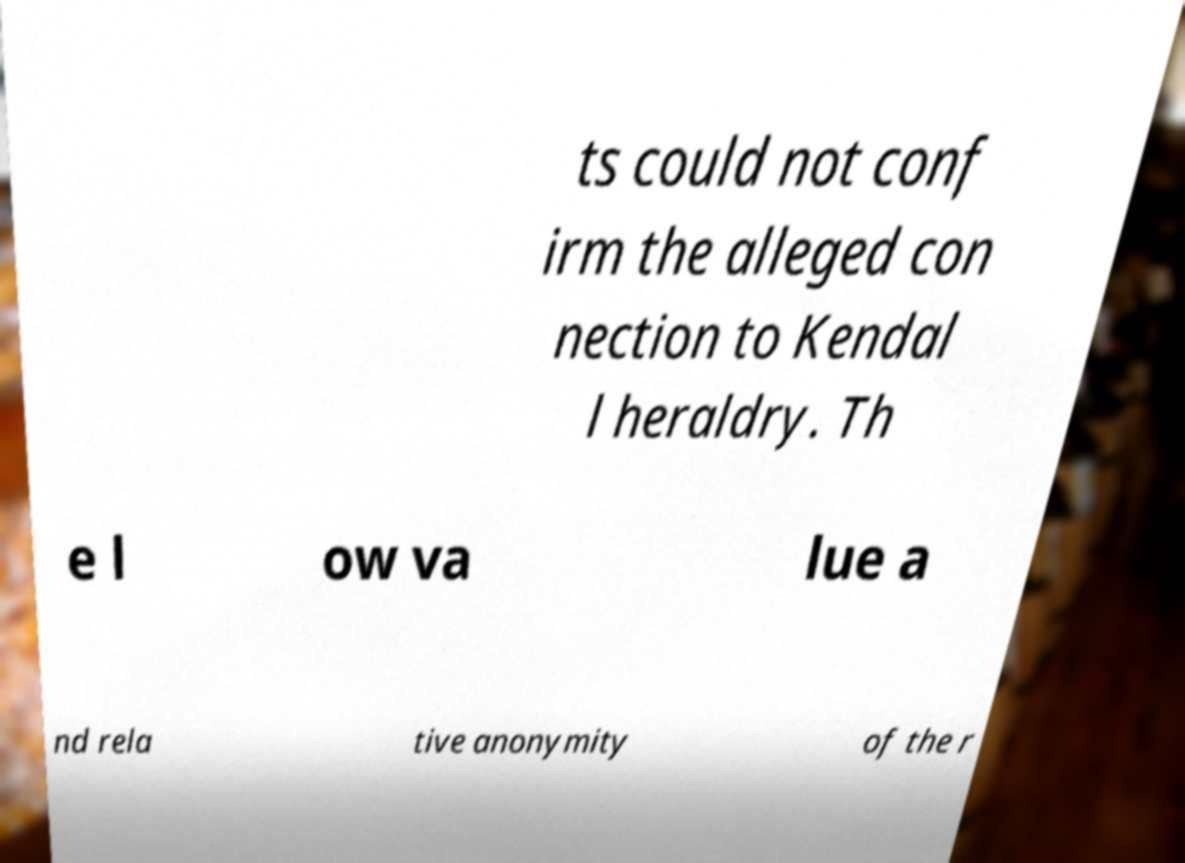For documentation purposes, I need the text within this image transcribed. Could you provide that? ts could not conf irm the alleged con nection to Kendal l heraldry. Th e l ow va lue a nd rela tive anonymity of the r 